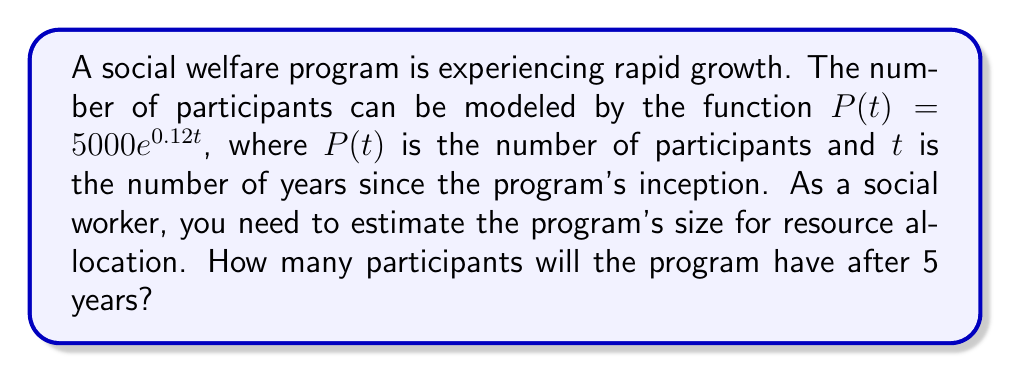What is the answer to this math problem? To solve this problem, we'll follow these steps:

1) We are given the exponential function: $P(t) = 5000e^{0.12t}$

2) We need to find $P(5)$, as we want to know the number of participants after 5 years.

3) Let's substitute $t = 5$ into the equation:

   $P(5) = 5000e^{0.12(5)}$

4) Simplify the exponent:
   
   $P(5) = 5000e^{0.6}$

5) Now, we need to calculate $e^{0.6}$. Using a calculator:

   $e^{0.6} \approx 1.8221$

6) Multiply this by 5000:

   $P(5) = 5000 \times 1.8221 \approx 9110.5$

7) Since we're dealing with people, we round down to the nearest whole number.

Therefore, after 5 years, the program will have approximately 9110 participants.
Answer: 9110 participants 